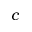<formula> <loc_0><loc_0><loc_500><loc_500>c</formula> 